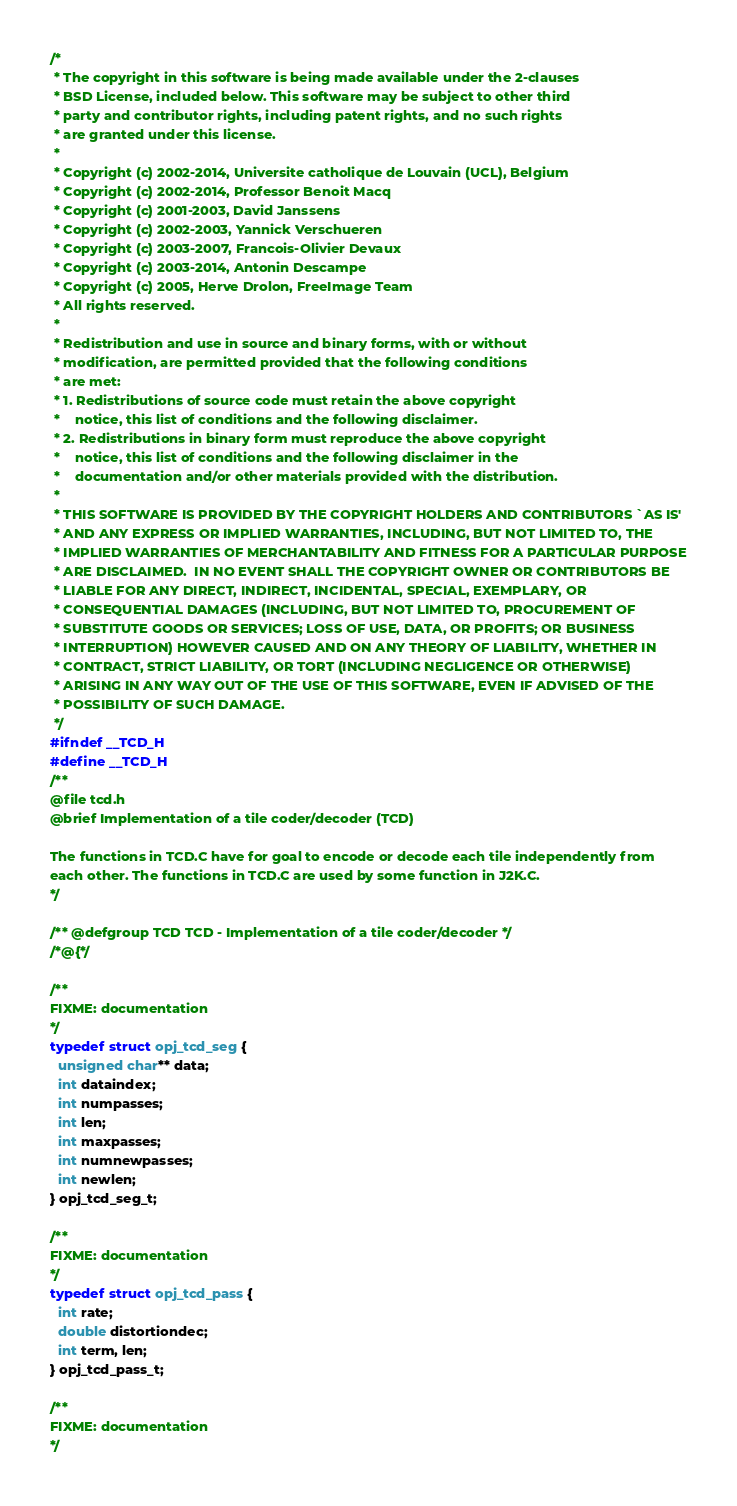<code> <loc_0><loc_0><loc_500><loc_500><_C_>/*
 * The copyright in this software is being made available under the 2-clauses 
 * BSD License, included below. This software may be subject to other third 
 * party and contributor rights, including patent rights, and no such rights
 * are granted under this license.
 *
 * Copyright (c) 2002-2014, Universite catholique de Louvain (UCL), Belgium
 * Copyright (c) 2002-2014, Professor Benoit Macq
 * Copyright (c) 2001-2003, David Janssens
 * Copyright (c) 2002-2003, Yannick Verschueren
 * Copyright (c) 2003-2007, Francois-Olivier Devaux 
 * Copyright (c) 2003-2014, Antonin Descampe
 * Copyright (c) 2005, Herve Drolon, FreeImage Team
 * All rights reserved.
 *
 * Redistribution and use in source and binary forms, with or without
 * modification, are permitted provided that the following conditions
 * are met:
 * 1. Redistributions of source code must retain the above copyright
 *    notice, this list of conditions and the following disclaimer.
 * 2. Redistributions in binary form must reproduce the above copyright
 *    notice, this list of conditions and the following disclaimer in the
 *    documentation and/or other materials provided with the distribution.
 *
 * THIS SOFTWARE IS PROVIDED BY THE COPYRIGHT HOLDERS AND CONTRIBUTORS `AS IS'
 * AND ANY EXPRESS OR IMPLIED WARRANTIES, INCLUDING, BUT NOT LIMITED TO, THE
 * IMPLIED WARRANTIES OF MERCHANTABILITY AND FITNESS FOR A PARTICULAR PURPOSE
 * ARE DISCLAIMED.  IN NO EVENT SHALL THE COPYRIGHT OWNER OR CONTRIBUTORS BE
 * LIABLE FOR ANY DIRECT, INDIRECT, INCIDENTAL, SPECIAL, EXEMPLARY, OR
 * CONSEQUENTIAL DAMAGES (INCLUDING, BUT NOT LIMITED TO, PROCUREMENT OF
 * SUBSTITUTE GOODS OR SERVICES; LOSS OF USE, DATA, OR PROFITS; OR BUSINESS
 * INTERRUPTION) HOWEVER CAUSED AND ON ANY THEORY OF LIABILITY, WHETHER IN
 * CONTRACT, STRICT LIABILITY, OR TORT (INCLUDING NEGLIGENCE OR OTHERWISE)
 * ARISING IN ANY WAY OUT OF THE USE OF THIS SOFTWARE, EVEN IF ADVISED OF THE
 * POSSIBILITY OF SUCH DAMAGE.
 */
#ifndef __TCD_H
#define __TCD_H
/**
@file tcd.h
@brief Implementation of a tile coder/decoder (TCD)

The functions in TCD.C have for goal to encode or decode each tile independently from
each other. The functions in TCD.C are used by some function in J2K.C.
*/

/** @defgroup TCD TCD - Implementation of a tile coder/decoder */
/*@{*/

/**
FIXME: documentation
*/
typedef struct opj_tcd_seg {
  unsigned char** data;
  int dataindex;
  int numpasses;
  int len;
  int maxpasses;
  int numnewpasses;
  int newlen;
} opj_tcd_seg_t;

/**
FIXME: documentation
*/
typedef struct opj_tcd_pass {
  int rate;
  double distortiondec;
  int term, len;
} opj_tcd_pass_t;

/**
FIXME: documentation
*/</code> 